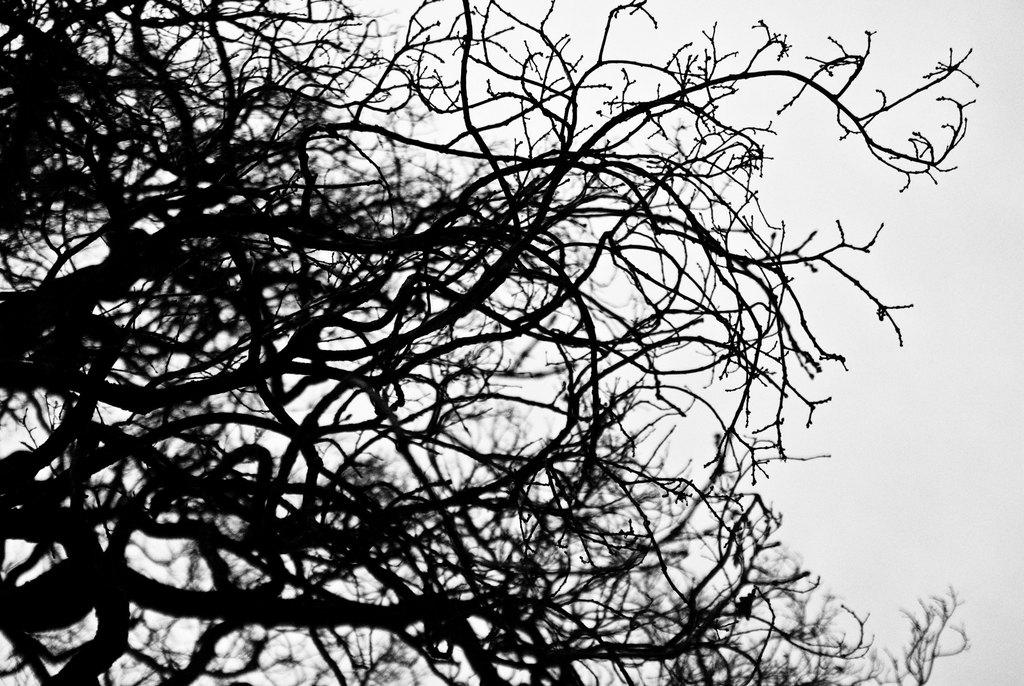What is the color scheme of the image? The image is black and white. What can be seen in the image? There are dry branches of a tree in the image. How many giants are visible in the image? There are no giants present in the image; it features dry branches of a tree. What type of cup is being used to play the game in the image? There is no cup or game present in the image; it only features dry branches of a tree. 